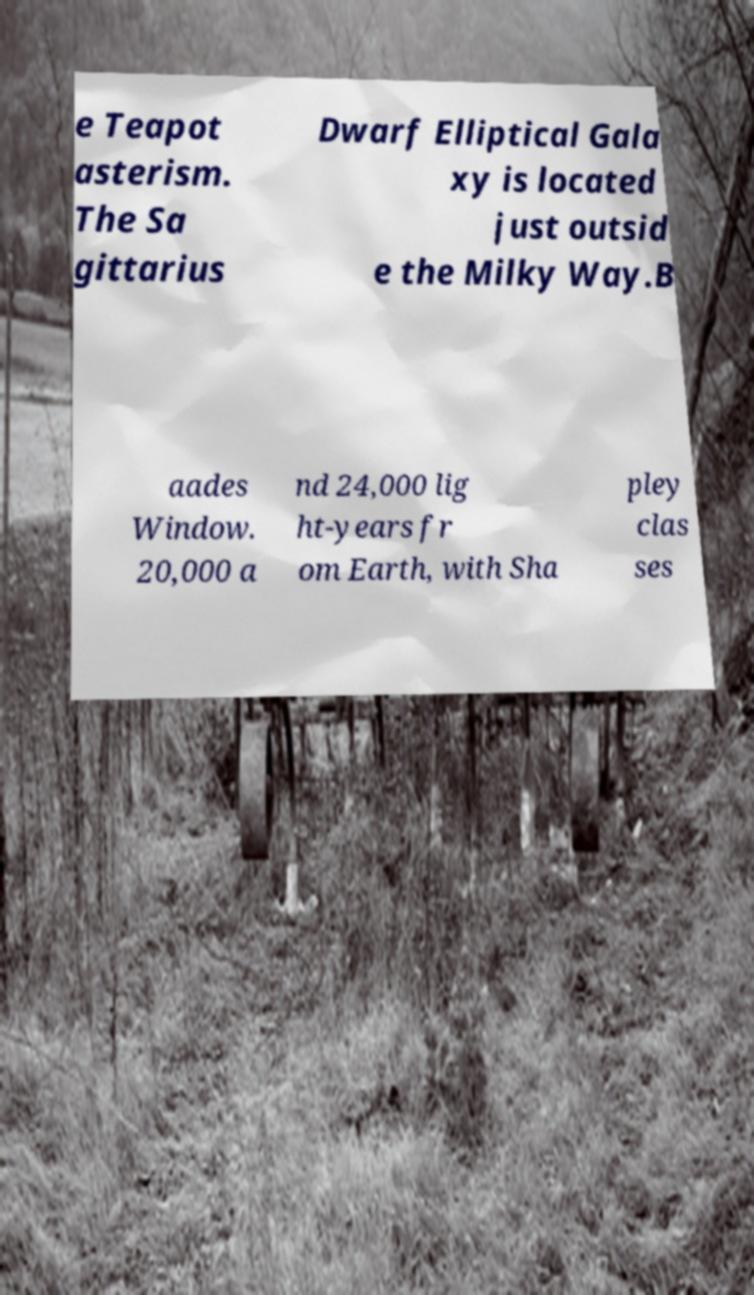There's text embedded in this image that I need extracted. Can you transcribe it verbatim? e Teapot asterism. The Sa gittarius Dwarf Elliptical Gala xy is located just outsid e the Milky Way.B aades Window. 20,000 a nd 24,000 lig ht-years fr om Earth, with Sha pley clas ses 